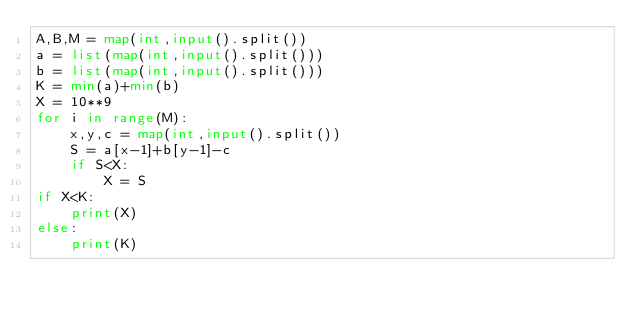<code> <loc_0><loc_0><loc_500><loc_500><_Python_>A,B,M = map(int,input().split())
a = list(map(int,input().split()))
b = list(map(int,input().split()))
K = min(a)+min(b)
X = 10**9
for i in range(M):
    x,y,c = map(int,input().split())
    S = a[x-1]+b[y-1]-c
    if S<X:
        X = S
if X<K:
    print(X)
else:
    print(K)</code> 